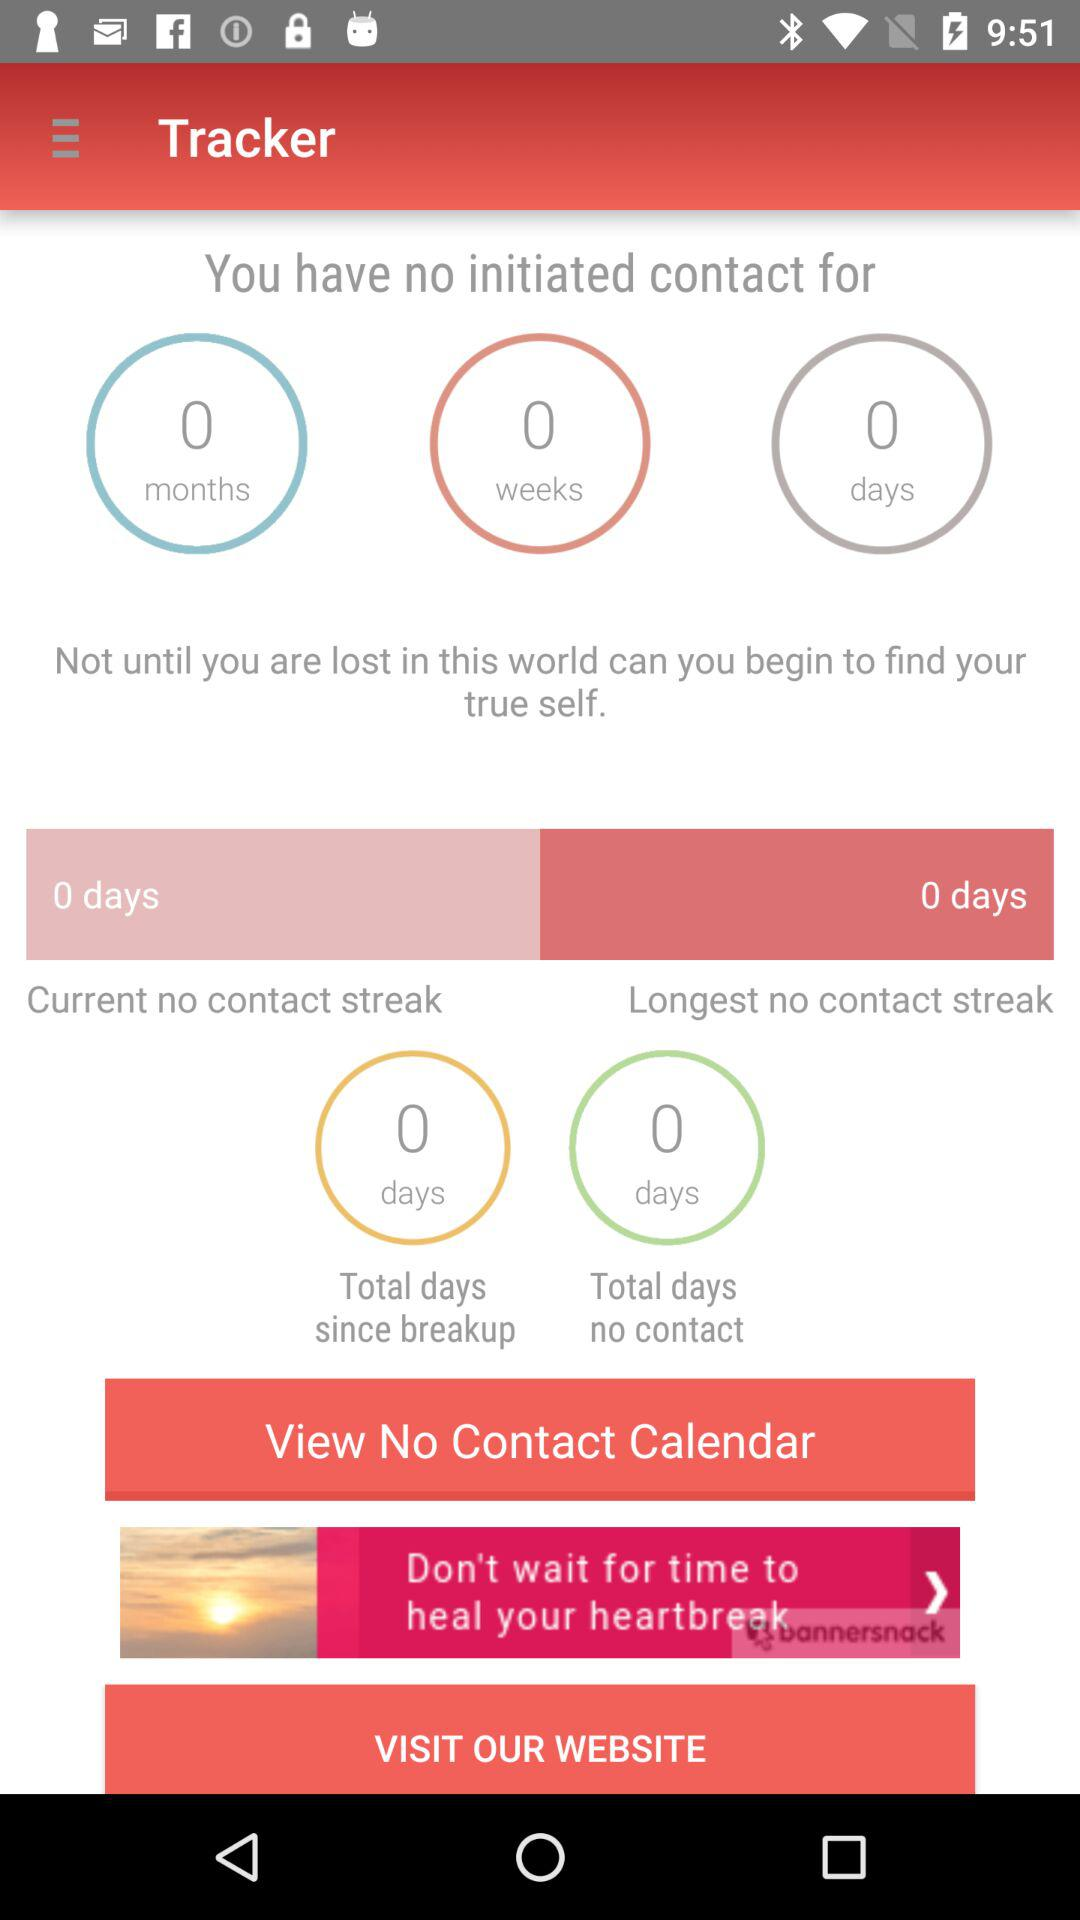How many days are shown in the total days since the breakup? The total days shown since the breakup is 0. 